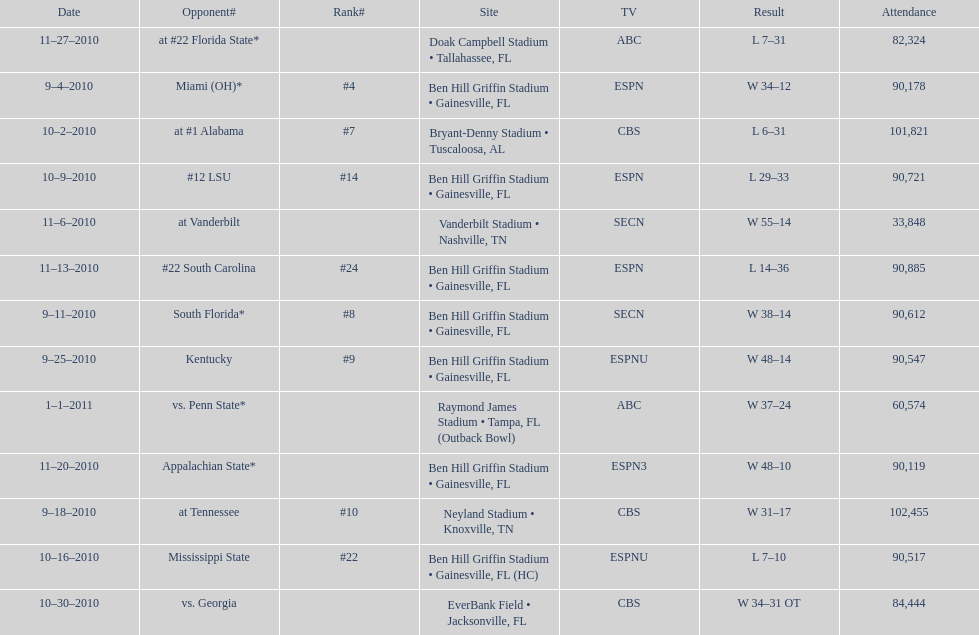What was the most the university of florida won by? 41 points. 